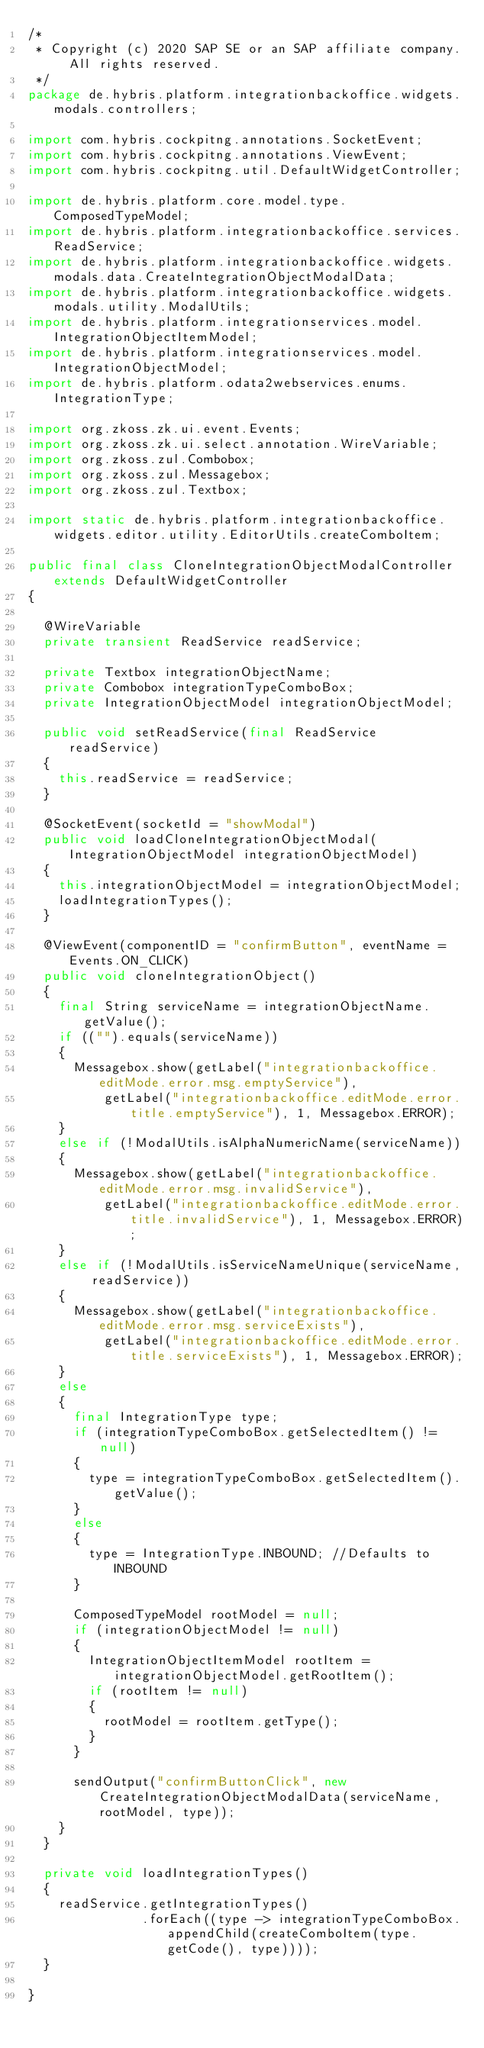<code> <loc_0><loc_0><loc_500><loc_500><_Java_>/*
 * Copyright (c) 2020 SAP SE or an SAP affiliate company. All rights reserved.
 */
package de.hybris.platform.integrationbackoffice.widgets.modals.controllers;

import com.hybris.cockpitng.annotations.SocketEvent;
import com.hybris.cockpitng.annotations.ViewEvent;
import com.hybris.cockpitng.util.DefaultWidgetController;

import de.hybris.platform.core.model.type.ComposedTypeModel;
import de.hybris.platform.integrationbackoffice.services.ReadService;
import de.hybris.platform.integrationbackoffice.widgets.modals.data.CreateIntegrationObjectModalData;
import de.hybris.platform.integrationbackoffice.widgets.modals.utility.ModalUtils;
import de.hybris.platform.integrationservices.model.IntegrationObjectItemModel;
import de.hybris.platform.integrationservices.model.IntegrationObjectModel;
import de.hybris.platform.odata2webservices.enums.IntegrationType;

import org.zkoss.zk.ui.event.Events;
import org.zkoss.zk.ui.select.annotation.WireVariable;
import org.zkoss.zul.Combobox;
import org.zkoss.zul.Messagebox;
import org.zkoss.zul.Textbox;

import static de.hybris.platform.integrationbackoffice.widgets.editor.utility.EditorUtils.createComboItem;

public final class CloneIntegrationObjectModalController extends DefaultWidgetController
{

	@WireVariable
	private transient ReadService readService;

	private Textbox integrationObjectName;
	private Combobox integrationTypeComboBox;
	private IntegrationObjectModel integrationObjectModel;

	public void setReadService(final ReadService readService)
	{
		this.readService = readService;
	}

	@SocketEvent(socketId = "showModal")
	public void loadCloneIntegrationObjectModal(IntegrationObjectModel integrationObjectModel)
	{
		this.integrationObjectModel = integrationObjectModel;
		loadIntegrationTypes();
	}

	@ViewEvent(componentID = "confirmButton", eventName = Events.ON_CLICK)
	public void cloneIntegrationObject()
	{
		final String serviceName = integrationObjectName.getValue();
		if (("").equals(serviceName))
		{
			Messagebox.show(getLabel("integrationbackoffice.editMode.error.msg.emptyService"),
					getLabel("integrationbackoffice.editMode.error.title.emptyService"), 1, Messagebox.ERROR);
		}
		else if (!ModalUtils.isAlphaNumericName(serviceName))
		{
			Messagebox.show(getLabel("integrationbackoffice.editMode.error.msg.invalidService"),
					getLabel("integrationbackoffice.editMode.error.title.invalidService"), 1, Messagebox.ERROR);
		}
		else if (!ModalUtils.isServiceNameUnique(serviceName, readService))
		{
			Messagebox.show(getLabel("integrationbackoffice.editMode.error.msg.serviceExists"),
					getLabel("integrationbackoffice.editMode.error.title.serviceExists"), 1, Messagebox.ERROR);
		}
		else
		{
			final IntegrationType type;
			if (integrationTypeComboBox.getSelectedItem() != null)
			{
				type = integrationTypeComboBox.getSelectedItem().getValue();
			}
			else
			{
				type = IntegrationType.INBOUND; //Defaults to INBOUND
			}

			ComposedTypeModel rootModel = null;
			if (integrationObjectModel != null)
			{
				IntegrationObjectItemModel rootItem = integrationObjectModel.getRootItem();
				if (rootItem != null)
				{
					rootModel = rootItem.getType();
				}
			}

			sendOutput("confirmButtonClick", new CreateIntegrationObjectModalData(serviceName, rootModel, type));
		}
	}

	private void loadIntegrationTypes()
	{
		readService.getIntegrationTypes()
		           .forEach((type -> integrationTypeComboBox.appendChild(createComboItem(type.getCode(), type))));
	}

}
</code> 